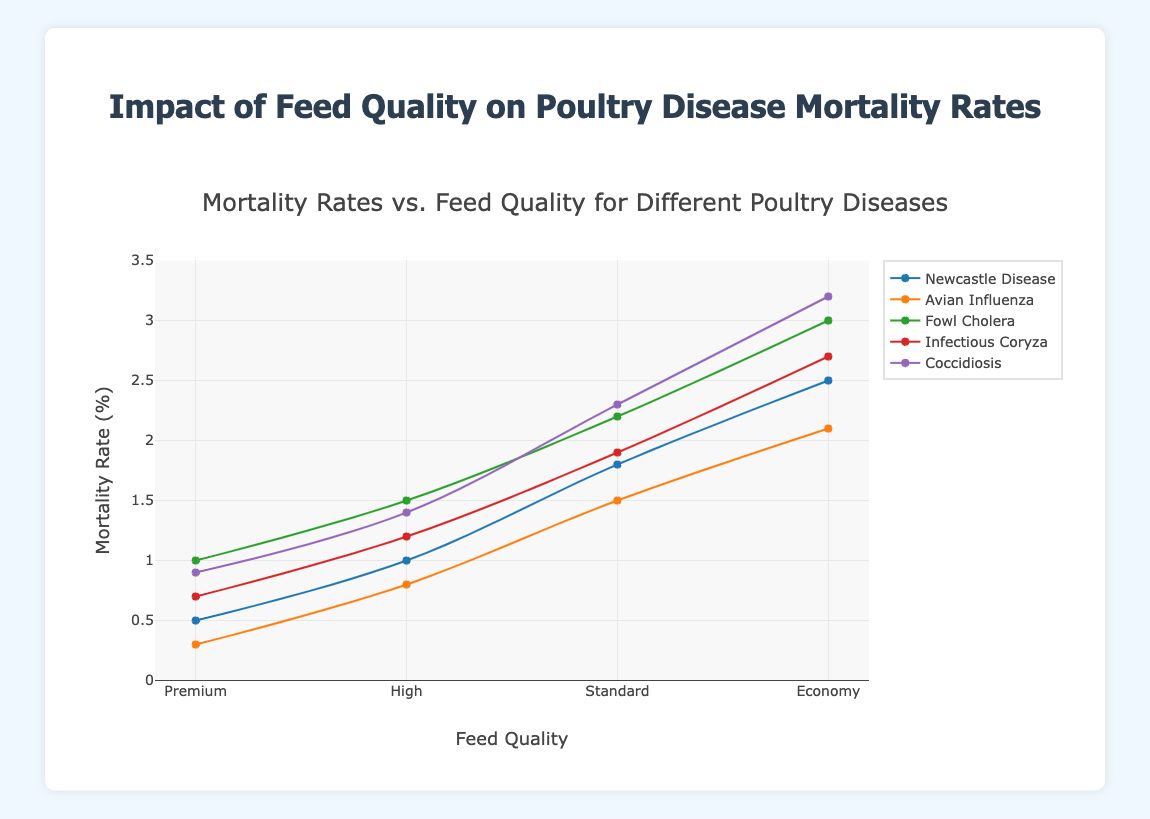What is the mortality rate for Newcastle Disease when the feed quality is Premium? Identify the feed quality "Premium" on the x-axis and look at the y-value where the "Newcastle Disease" line intersects it.
Answer: 0.5 Which disease has the highest mortality rate for High feed quality? Identify the point for "High" feed quality on the x-axis, check the y-values for all diseases, and find the highest one.
Answer: Fowl Cholera Compare the mortality rates of Avian Influenza for Standard feed quality versus Economy feed quality. Which one is higher? Locate the "Avian Influenza" line and compare its y-values at the "Standard" and "Economy" feed quality points. The y-value for "Economy" is higher than for "Standard".
Answer: Economy What is the average mortality rate of Coccidiosis across all feed qualities? Sum the mortality rates of Coccidiosis for all feed qualities and divide by the number of feed qualities (0.9 + 1.4 + 2.3 + 3.2) / 4 = 1.95.
Answer: 1.95 Which feed quality has the lowest overall mortality rate for all diseases? Examine the y-values for all diseases at each feed quality. The "Premium" feed quality has the lowest mortality rates for all diseases.
Answer: Premium Calculate the difference in mortality rate of Infectious Coryza between Premium and Economy feed qualities. Find the y-values for Infectious Coryza at Premium (0.7) and Economy (2.7) feed qualities and subtract 0.7 from 2.7 (2.7 - 0.7 = 2.0).
Answer: 2.0 Of all the diseases, which one shows the smallest increase in mortality rate as the feed quality decreases from Premium to Economy? Note the y-values for all diseases at the Premium and Economy feed qualities and calculate the differences. "Newcastle Disease" has the smallest increase (2.5 - 0.5 = 2.0).
Answer: Newcastle Disease Which disease shows the greatest variation in mortality rates across different feed qualities? Determine the disease with the largest range of y-values from Premium to Economy. "Coccidiosis" shows the greatest variation (3.2 - 0.9 = 2.3).
Answer: Coccidiosis What's the total sum of mortality rates for Fowl Cholera across all feed qualities? Add the y-values for Fowl Cholera across all feed qualities (1.0 + 1.5 + 2.2 + 3.0) = 7.7.
Answer: 7.7 